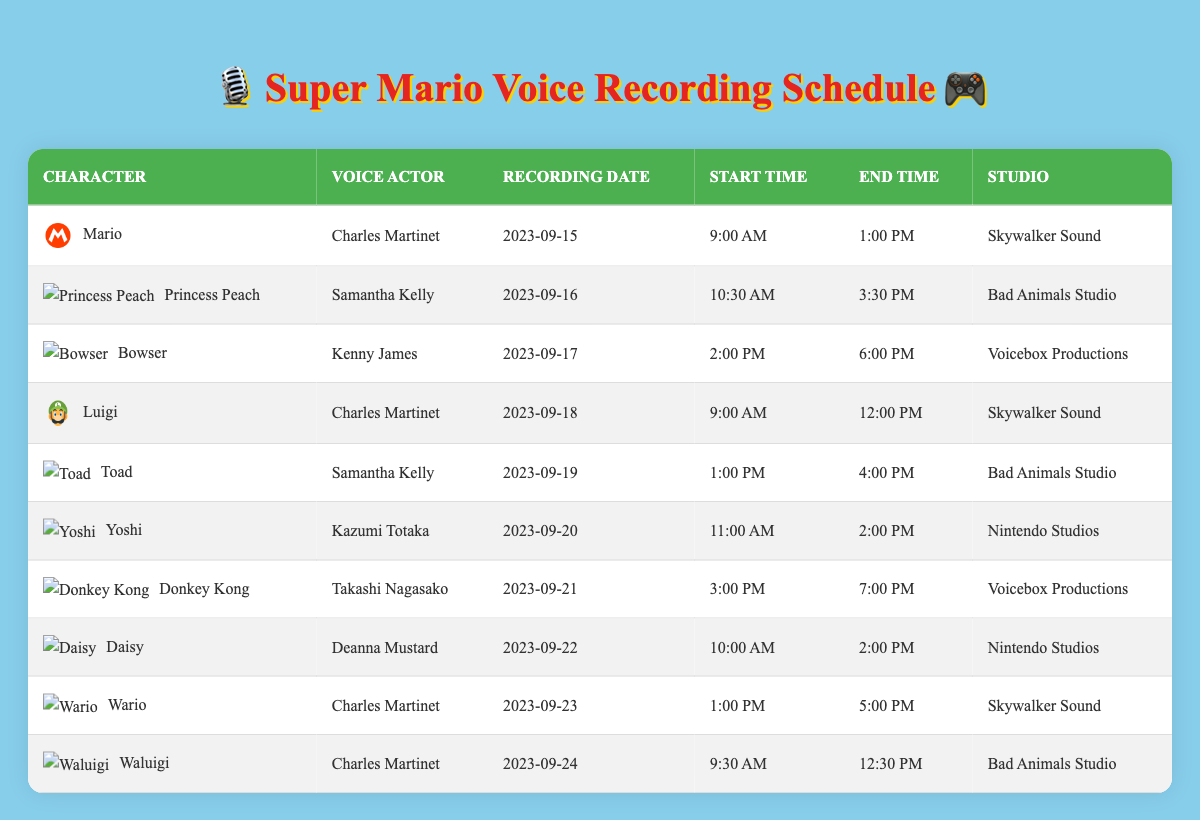What date is Bowser's recording session? The recording date for Bowser is listed in the table, specifically in the row for Bowser where the recording date is provided.
Answer: 2023-09-17 Who is the voice actor for Princess Peach? The voice actor's name for Princess Peach is mentioned in the table next to the character's name.
Answer: Samantha Kelly Is Charles Martinet scheduled to record voiceovers for more than two characters? By counting the rows, we find that Charles Martinet is scheduled for four characters: Mario, Luigi, Wario, and Waluigi. Thus, it confirms that he is indeed recording for more than two characters.
Answer: Yes What is the total duration for Toad's recording session? Toad's session starts at 1:00 PM and ends at 4:00 PM. To find the duration, subtract the start time from the end time: 4:00 PM - 1:00 PM = 3 hours.
Answer: 3 hours On which studio is Yoshi's recording session scheduled? The studio for Yoshi's recording session is specified in the corresponding row for Yoshi, directly available in the table.
Answer: Nintendo Studios How many sessions are scheduled at Skywalker Sound? Looking through the table, we identify sessions at Skywalker Sound for Mario, Luigi, and Wario, giving us a total of three sessions.
Answer: 3 sessions What is the recording time difference between Bowser and Donkey Kong? Bowser's session runs from 2:00 PM to 6:00 PM, giving him 4 hours of recording time. Donkey Kong's session runs from 3:00 PM to 7:00 PM, giving him 4 hours as well. Since both have the same duration, the time difference is zero.
Answer: 0 hours Which characters are recorded at Bad Animals Studio? By examining the table for entries that mention Bad Animals Studio, we find Princess Peach and Toad, meaning these are the characters recorded there.
Answer: Princess Peach, Toad Is there any recording scheduled on September 24th? Checking the table for September 24th reveals that there is a session scheduled for Waluigi on that date.
Answer: Yes 